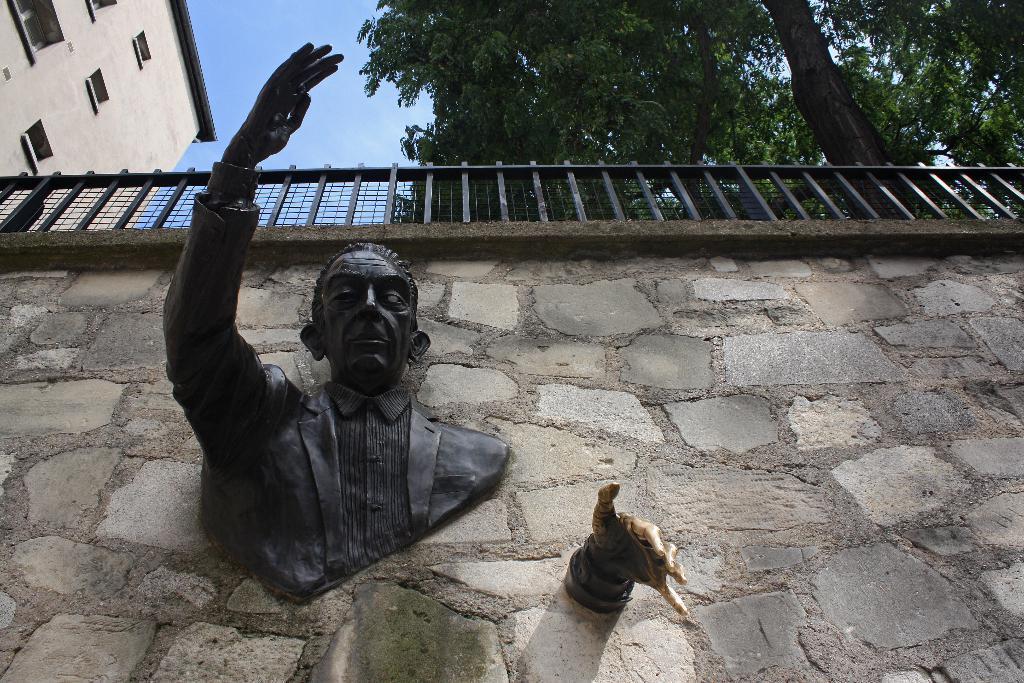How would you summarize this image in a sentence or two? This picture is clicked outside. In the foreground there is a sculpture of a person and a sculpture of a hand attached to the stone wall. At the top we can see the sky, building, tree and a guard rail. 